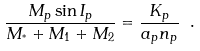Convert formula to latex. <formula><loc_0><loc_0><loc_500><loc_500>\frac { M _ { p } \sin { I _ { p } } } { M _ { ^ { * } } + M _ { 1 } + M _ { 2 } } = \frac { K _ { p } } { a _ { p } n _ { p } } \ .</formula> 